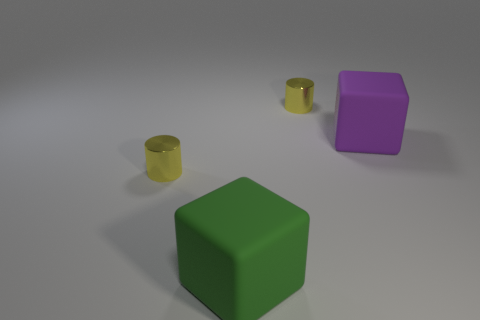Add 3 large brown metallic cylinders. How many objects exist? 7 Subtract 0 green spheres. How many objects are left? 4 Subtract all big green rubber cubes. Subtract all big purple objects. How many objects are left? 2 Add 4 big purple rubber cubes. How many big purple rubber cubes are left? 5 Add 2 purple blocks. How many purple blocks exist? 3 